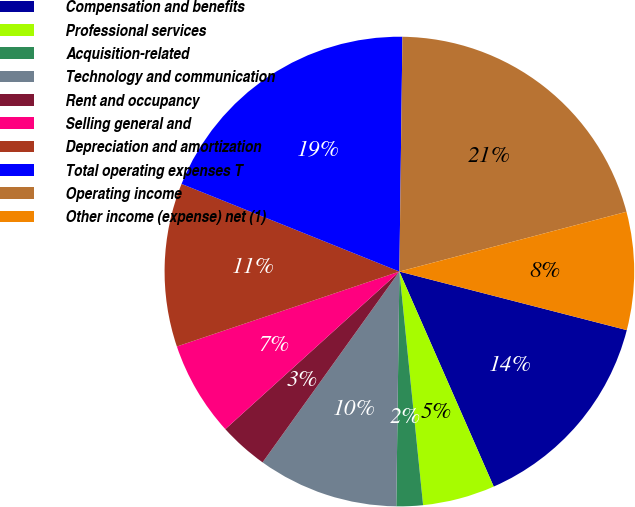<chart> <loc_0><loc_0><loc_500><loc_500><pie_chart><fcel>Compensation and benefits<fcel>Professional services<fcel>Acquisition-related<fcel>Technology and communication<fcel>Rent and occupancy<fcel>Selling general and<fcel>Depreciation and amortization<fcel>Total operating expenses T<fcel>Operating income<fcel>Other income (expense) net (1)<nl><fcel>14.41%<fcel>4.97%<fcel>1.82%<fcel>9.69%<fcel>3.39%<fcel>6.54%<fcel>11.26%<fcel>19.12%<fcel>20.7%<fcel>8.11%<nl></chart> 